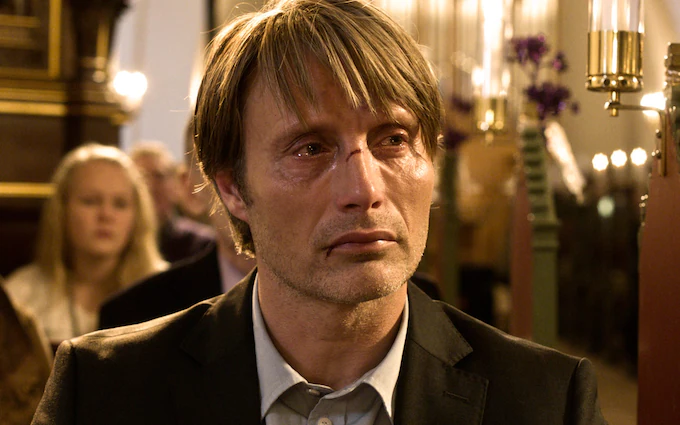Provide a short scenario that explains why the man is in this emotional state. The man is attending the funeral of a close friend. The church holds many memories for him, and standing here, in the midst of the ceremony, he can't help but reflect on the fragility of life and the deep bonds he shared with the departed. The weight of loss is overwhelming, bridging the past with the present sorrow. 